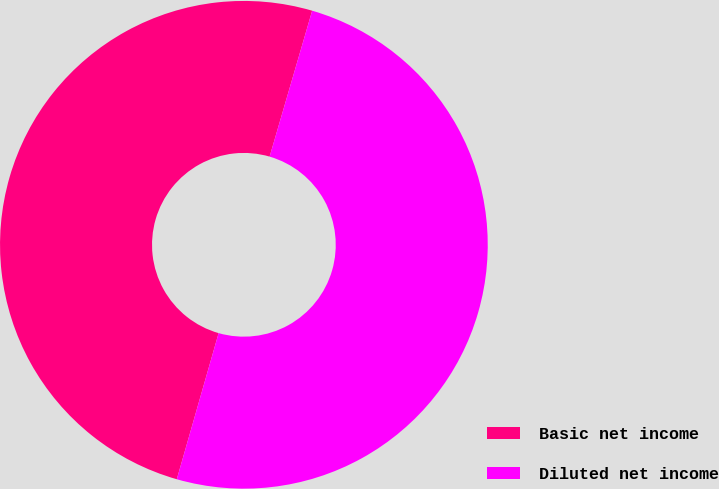Convert chart. <chart><loc_0><loc_0><loc_500><loc_500><pie_chart><fcel>Basic net income<fcel>Diluted net income<nl><fcel>50.08%<fcel>49.92%<nl></chart> 